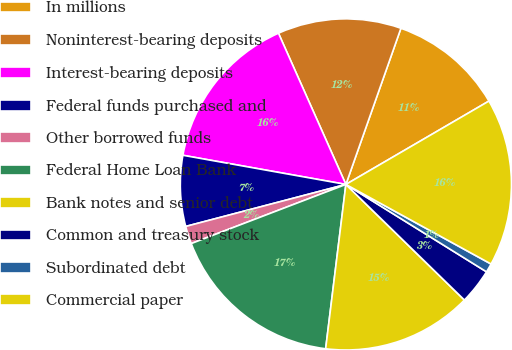<chart> <loc_0><loc_0><loc_500><loc_500><pie_chart><fcel>In millions<fcel>Noninterest-bearing deposits<fcel>Interest-bearing deposits<fcel>Federal funds purchased and<fcel>Other borrowed funds<fcel>Federal Home Loan Bank<fcel>Bank notes and senior debt<fcel>Common and treasury stock<fcel>Subordinated debt<fcel>Commercial paper<nl><fcel>11.21%<fcel>12.07%<fcel>15.51%<fcel>6.9%<fcel>1.73%<fcel>17.24%<fcel>14.65%<fcel>3.45%<fcel>0.87%<fcel>16.38%<nl></chart> 